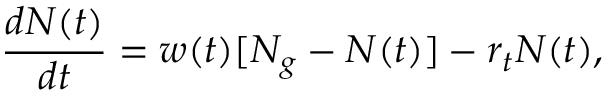<formula> <loc_0><loc_0><loc_500><loc_500>\frac { d N ( t ) } { d t } = w ( t ) [ N _ { g } - N ( t ) ] - r _ { t } N ( t ) ,</formula> 